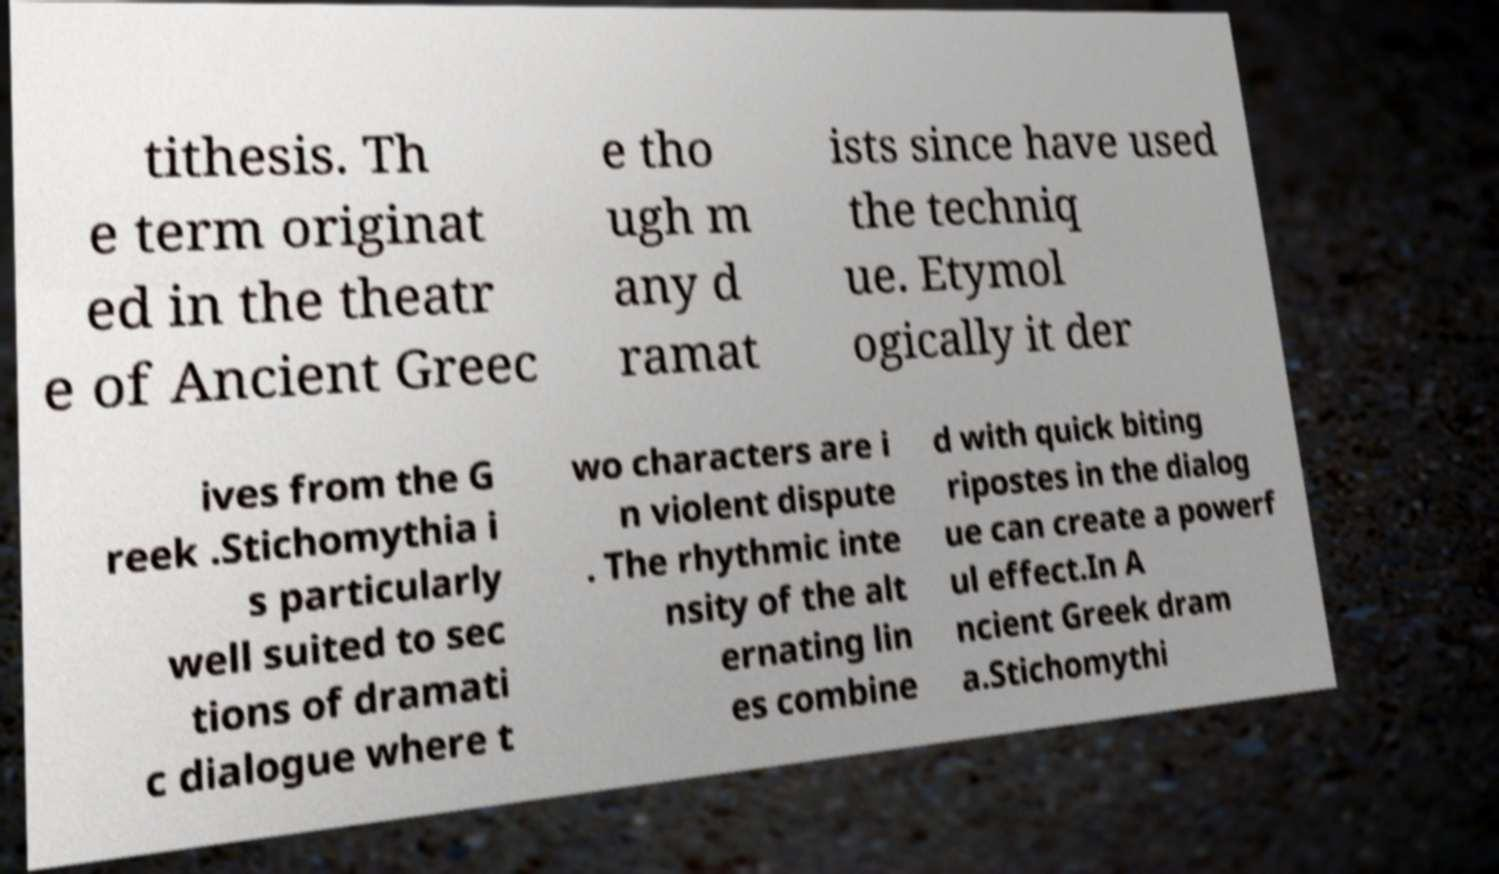Could you assist in decoding the text presented in this image and type it out clearly? tithesis. Th e term originat ed in the theatr e of Ancient Greec e tho ugh m any d ramat ists since have used the techniq ue. Etymol ogically it der ives from the G reek .Stichomythia i s particularly well suited to sec tions of dramati c dialogue where t wo characters are i n violent dispute . The rhythmic inte nsity of the alt ernating lin es combine d with quick biting ripostes in the dialog ue can create a powerf ul effect.In A ncient Greek dram a.Stichomythi 